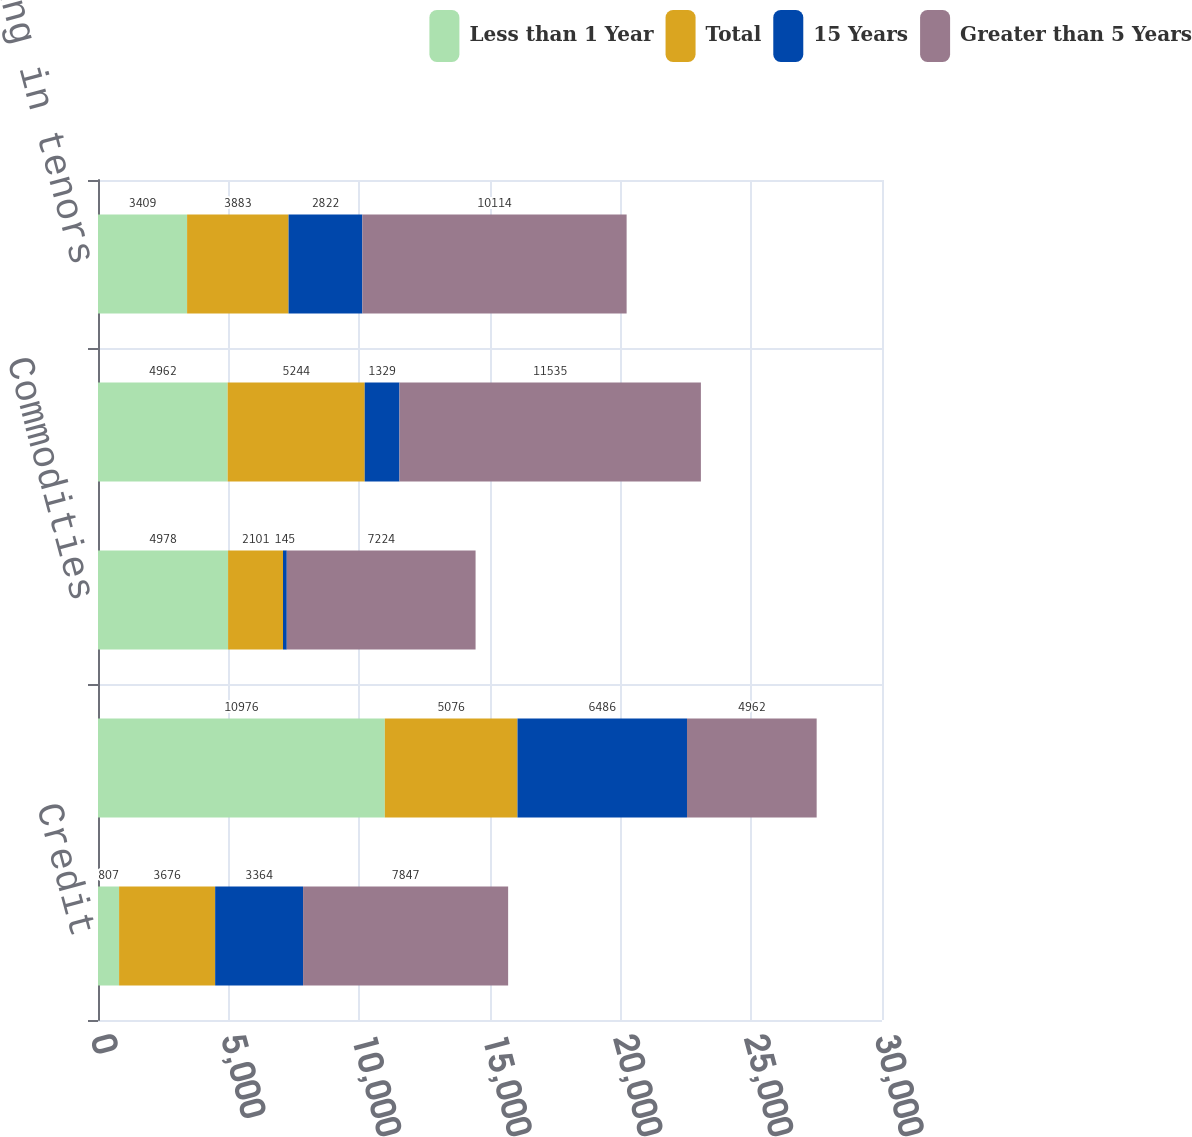Convert chart. <chart><loc_0><loc_0><loc_500><loc_500><stacked_bar_chart><ecel><fcel>Credit<fcel>Currencies<fcel>Commodities<fcel>Equities<fcel>Counterparty netting in tenors<nl><fcel>Less than 1 Year<fcel>807<fcel>10976<fcel>4978<fcel>4962<fcel>3409<nl><fcel>Total<fcel>3676<fcel>5076<fcel>2101<fcel>5244<fcel>3883<nl><fcel>15 Years<fcel>3364<fcel>6486<fcel>145<fcel>1329<fcel>2822<nl><fcel>Greater than 5 Years<fcel>7847<fcel>4962<fcel>7224<fcel>11535<fcel>10114<nl></chart> 